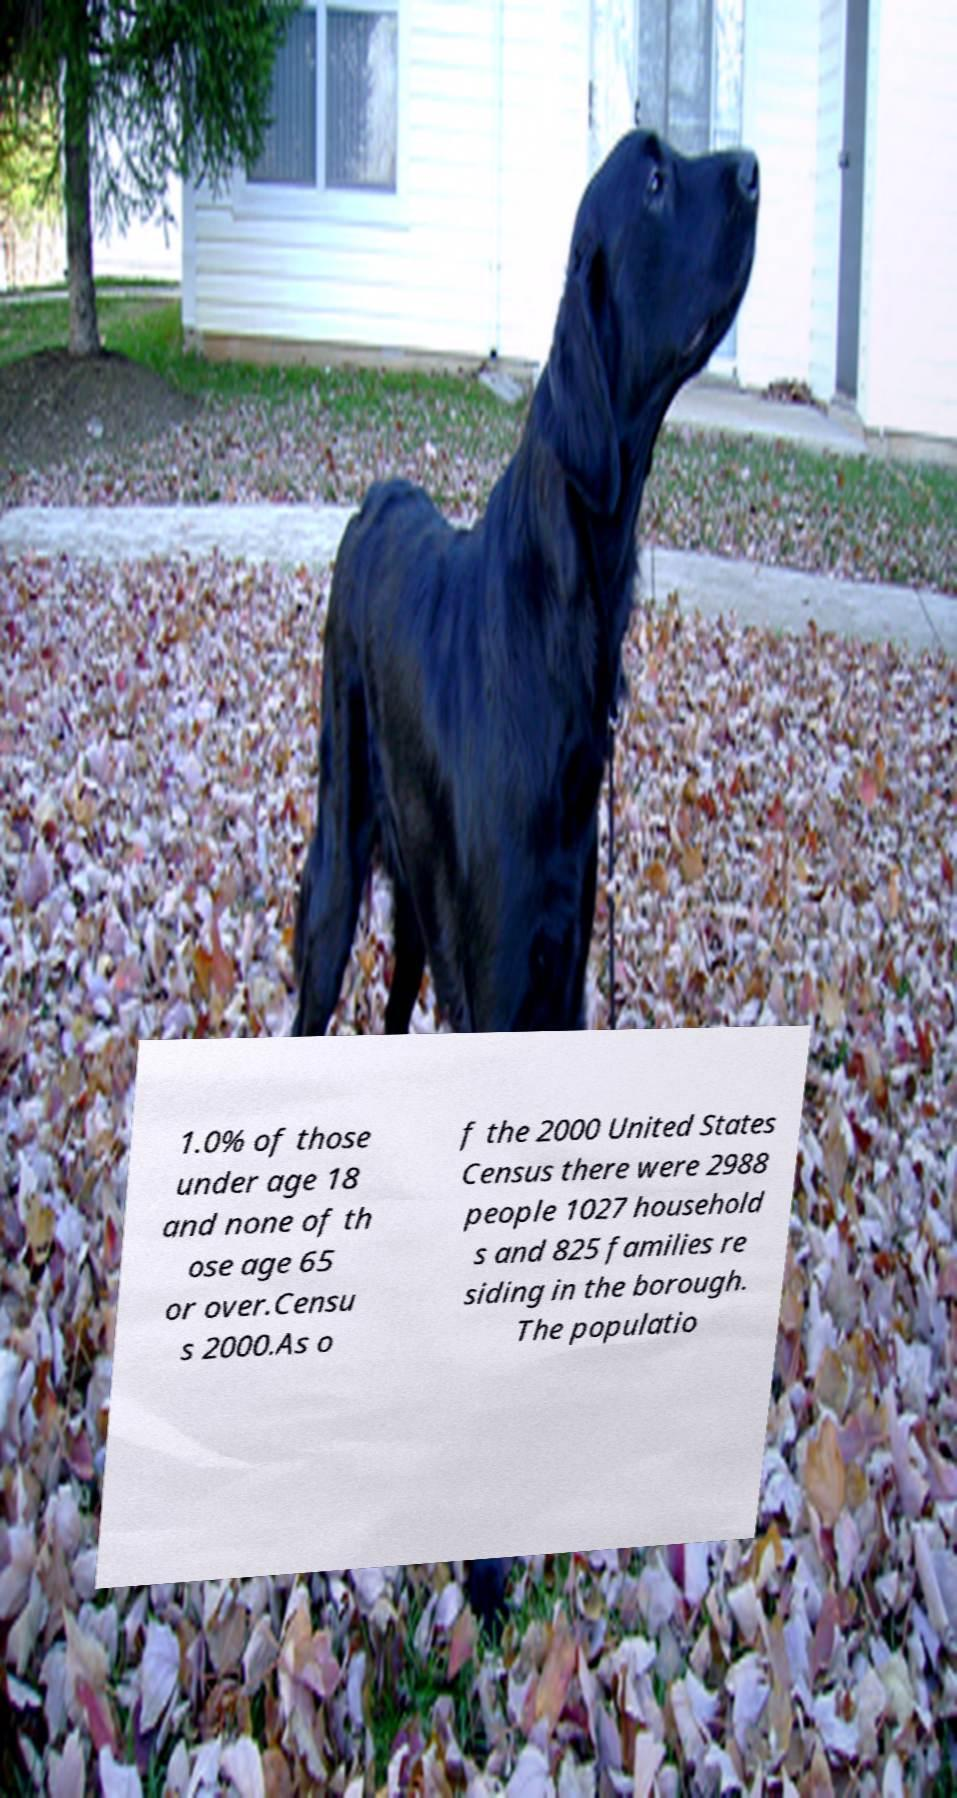Please read and relay the text visible in this image. What does it say? 1.0% of those under age 18 and none of th ose age 65 or over.Censu s 2000.As o f the 2000 United States Census there were 2988 people 1027 household s and 825 families re siding in the borough. The populatio 